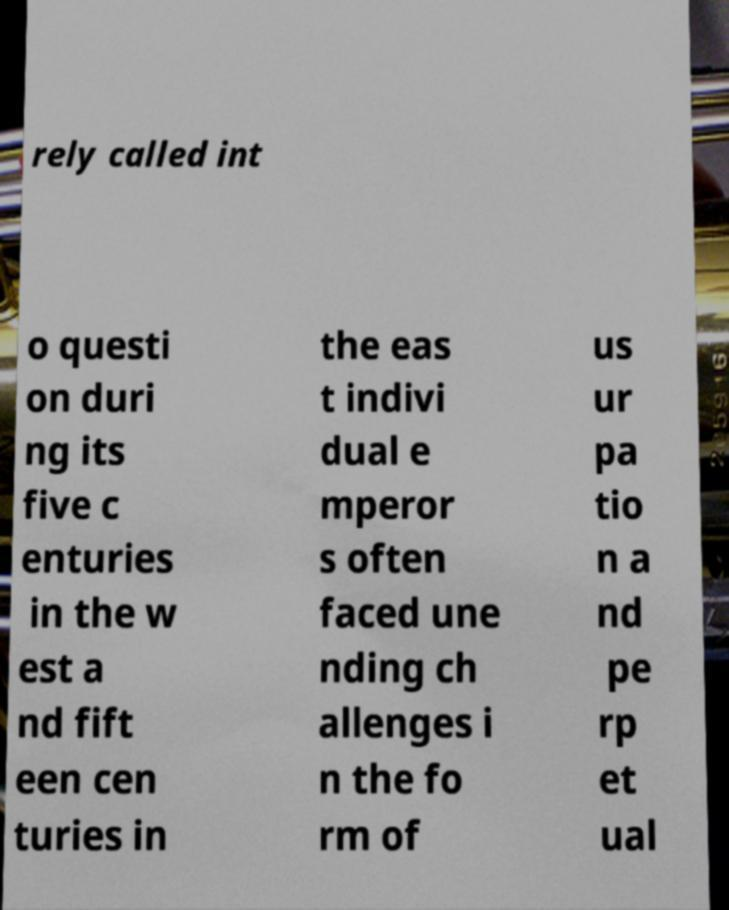Could you extract and type out the text from this image? rely called int o questi on duri ng its five c enturies in the w est a nd fift een cen turies in the eas t indivi dual e mperor s often faced une nding ch allenges i n the fo rm of us ur pa tio n a nd pe rp et ual 